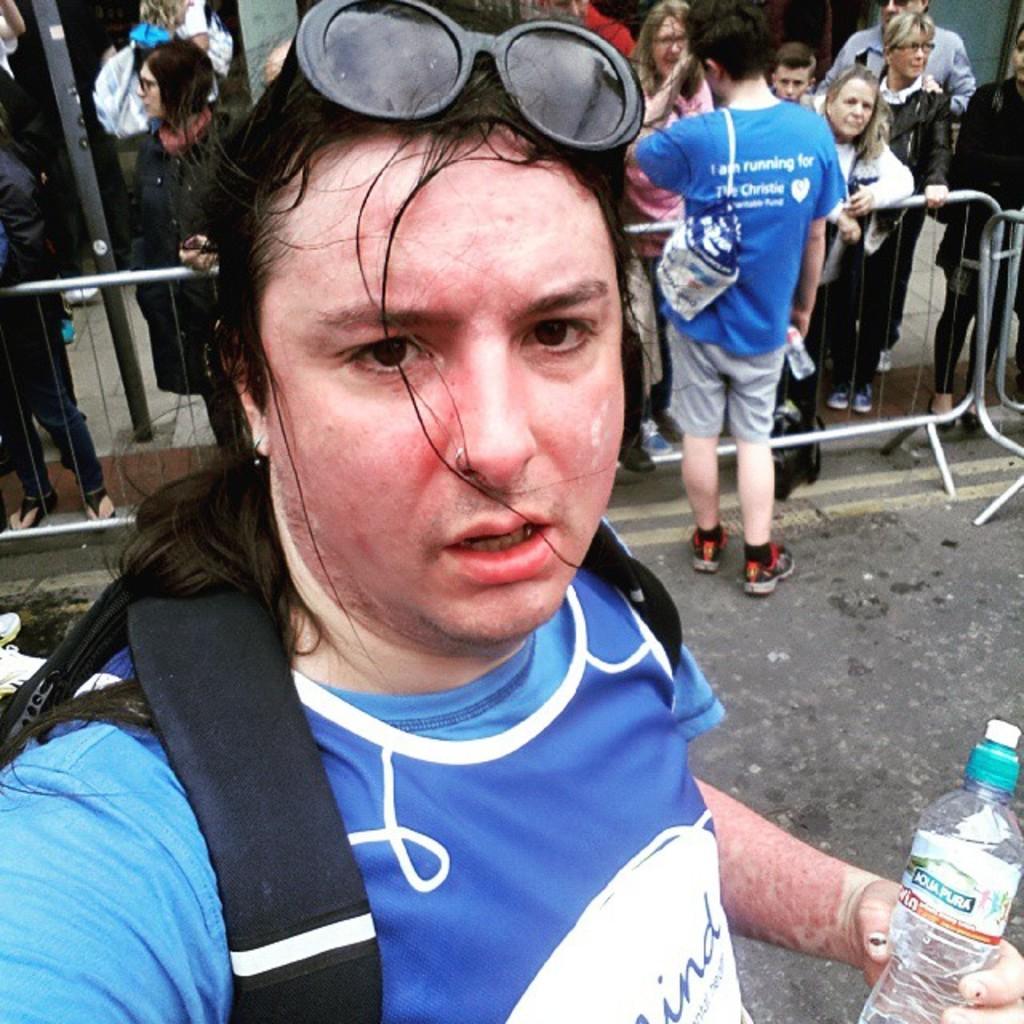Can you describe this image briefly? In the image I can see a person who is wearing the backpack, spectacles and holding the bottle and the other person who is standing in front of the fencing and also I can see some other people who are standing to the other side of the fencing. 